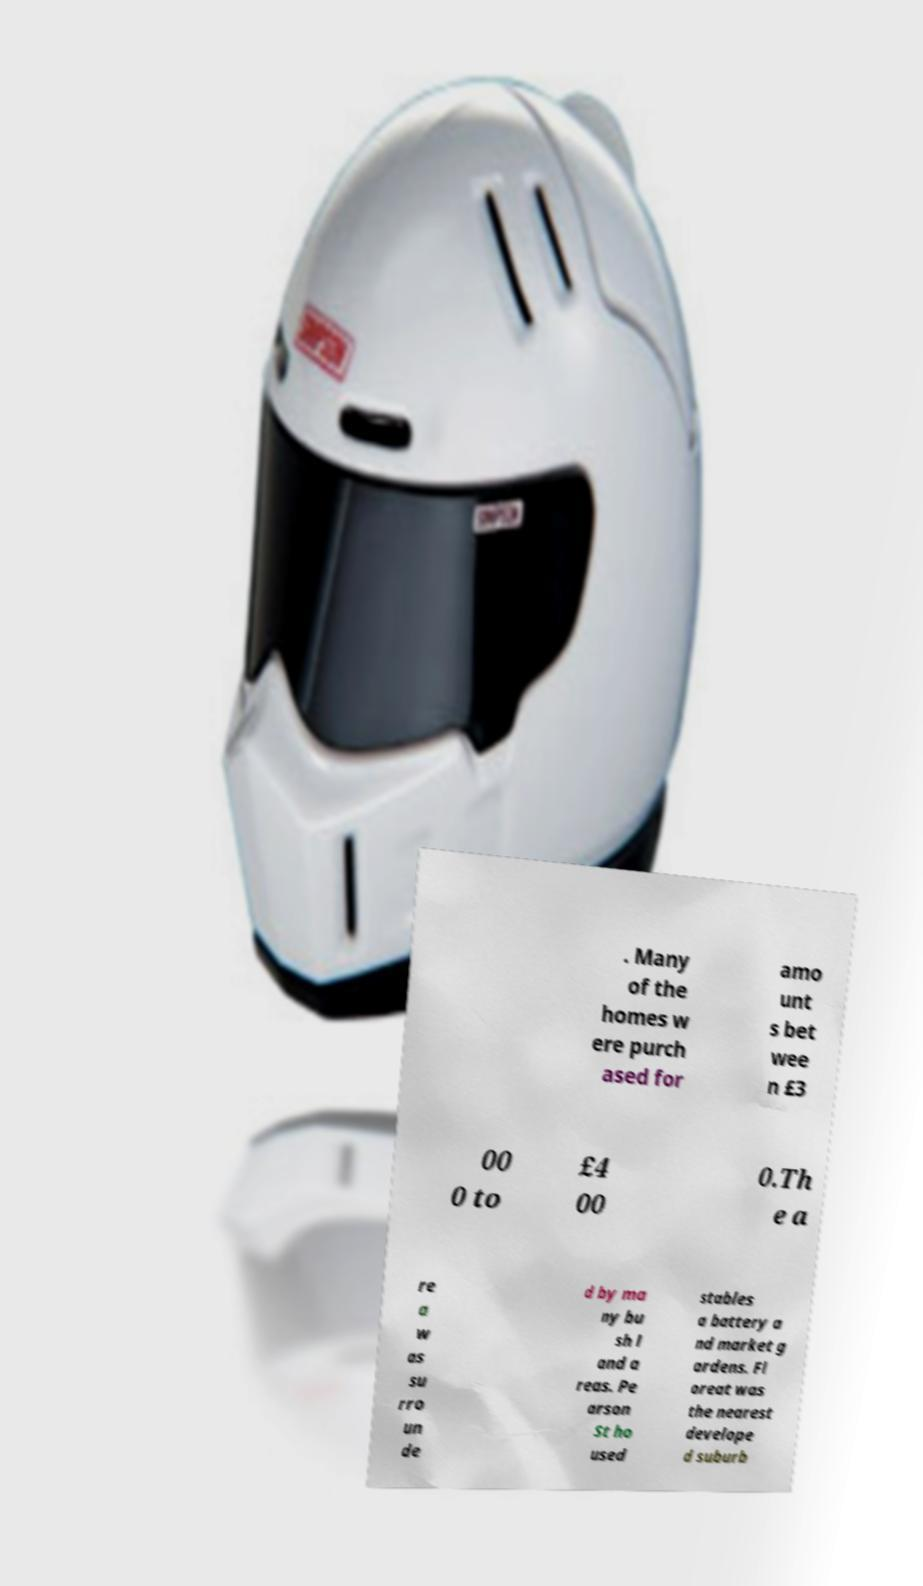Could you assist in decoding the text presented in this image and type it out clearly? . Many of the homes w ere purch ased for amo unt s bet wee n £3 00 0 to £4 00 0.Th e a re a w as su rro un de d by ma ny bu sh l and a reas. Pe arson St ho used stables a battery a nd market g ardens. Fl oreat was the nearest develope d suburb 